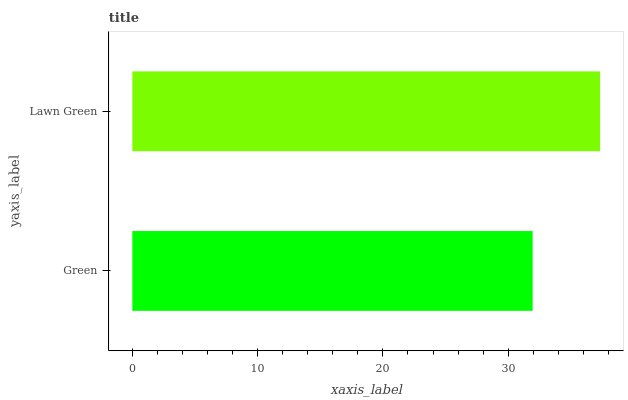Is Green the minimum?
Answer yes or no. Yes. Is Lawn Green the maximum?
Answer yes or no. Yes. Is Lawn Green the minimum?
Answer yes or no. No. Is Lawn Green greater than Green?
Answer yes or no. Yes. Is Green less than Lawn Green?
Answer yes or no. Yes. Is Green greater than Lawn Green?
Answer yes or no. No. Is Lawn Green less than Green?
Answer yes or no. No. Is Lawn Green the high median?
Answer yes or no. Yes. Is Green the low median?
Answer yes or no. Yes. Is Green the high median?
Answer yes or no. No. Is Lawn Green the low median?
Answer yes or no. No. 